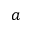Convert formula to latex. <formula><loc_0><loc_0><loc_500><loc_500>a</formula> 